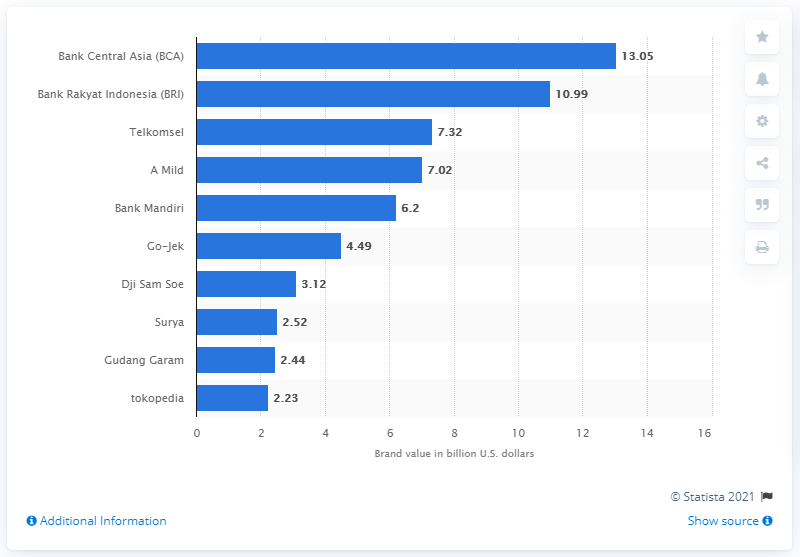Which Indonesian company had the highest brand value according to the chart? According to the chart, Bank Central Asia (BCA) had the highest brand value, listed at 13.05 billion U.S. dollars. 